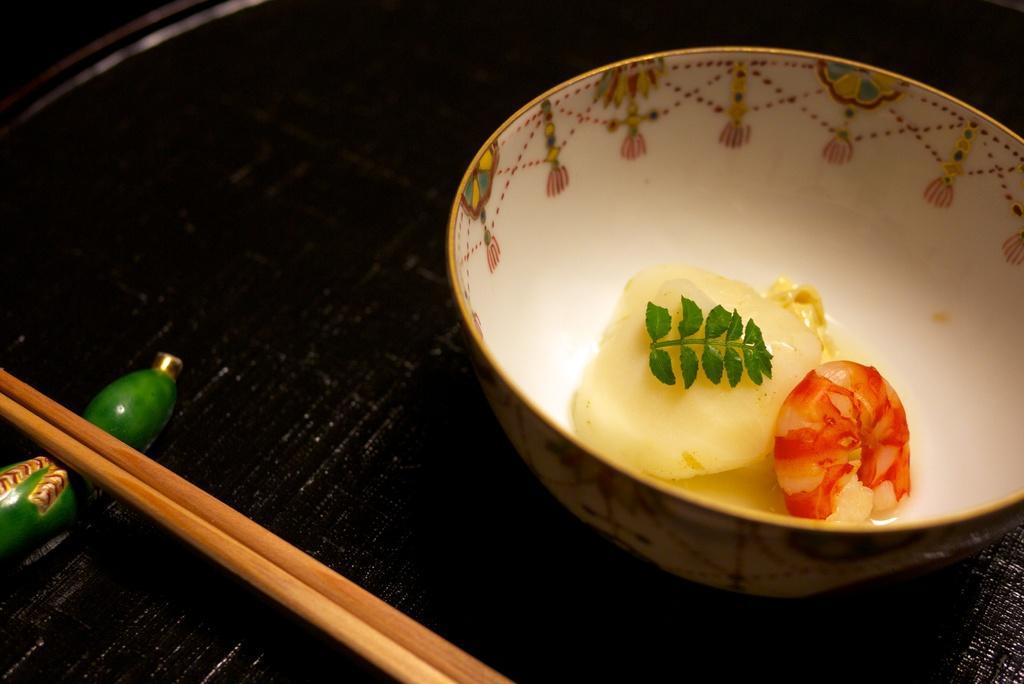In one or two sentences, can you explain what this image depicts? In the middle of the image there is a table. Top right side of the image there is a bowl and food. Bottom left side of the image there are chopsticks. 